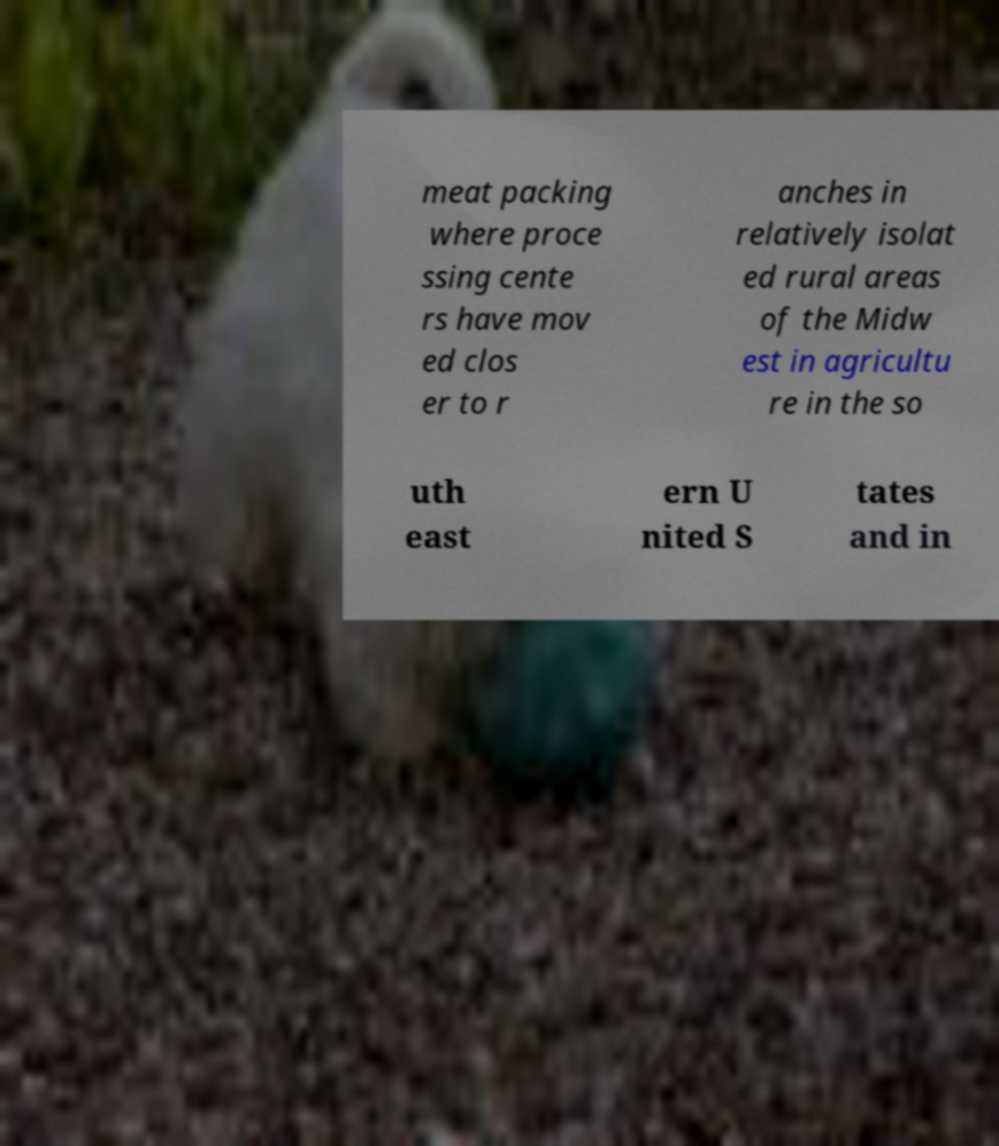There's text embedded in this image that I need extracted. Can you transcribe it verbatim? meat packing where proce ssing cente rs have mov ed clos er to r anches in relatively isolat ed rural areas of the Midw est in agricultu re in the so uth east ern U nited S tates and in 